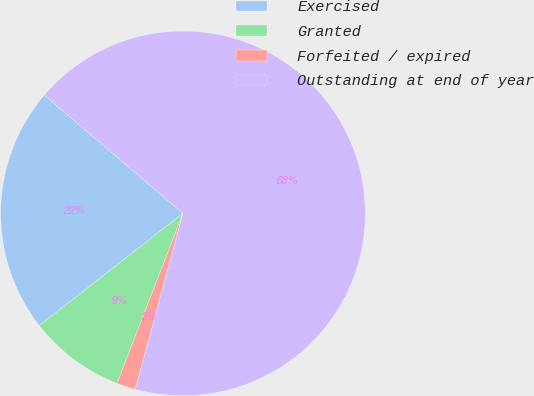<chart> <loc_0><loc_0><loc_500><loc_500><pie_chart><fcel>Exercised<fcel>Granted<fcel>Forfeited / expired<fcel>Outstanding at end of year<nl><fcel>21.8%<fcel>8.55%<fcel>1.68%<fcel>67.97%<nl></chart> 